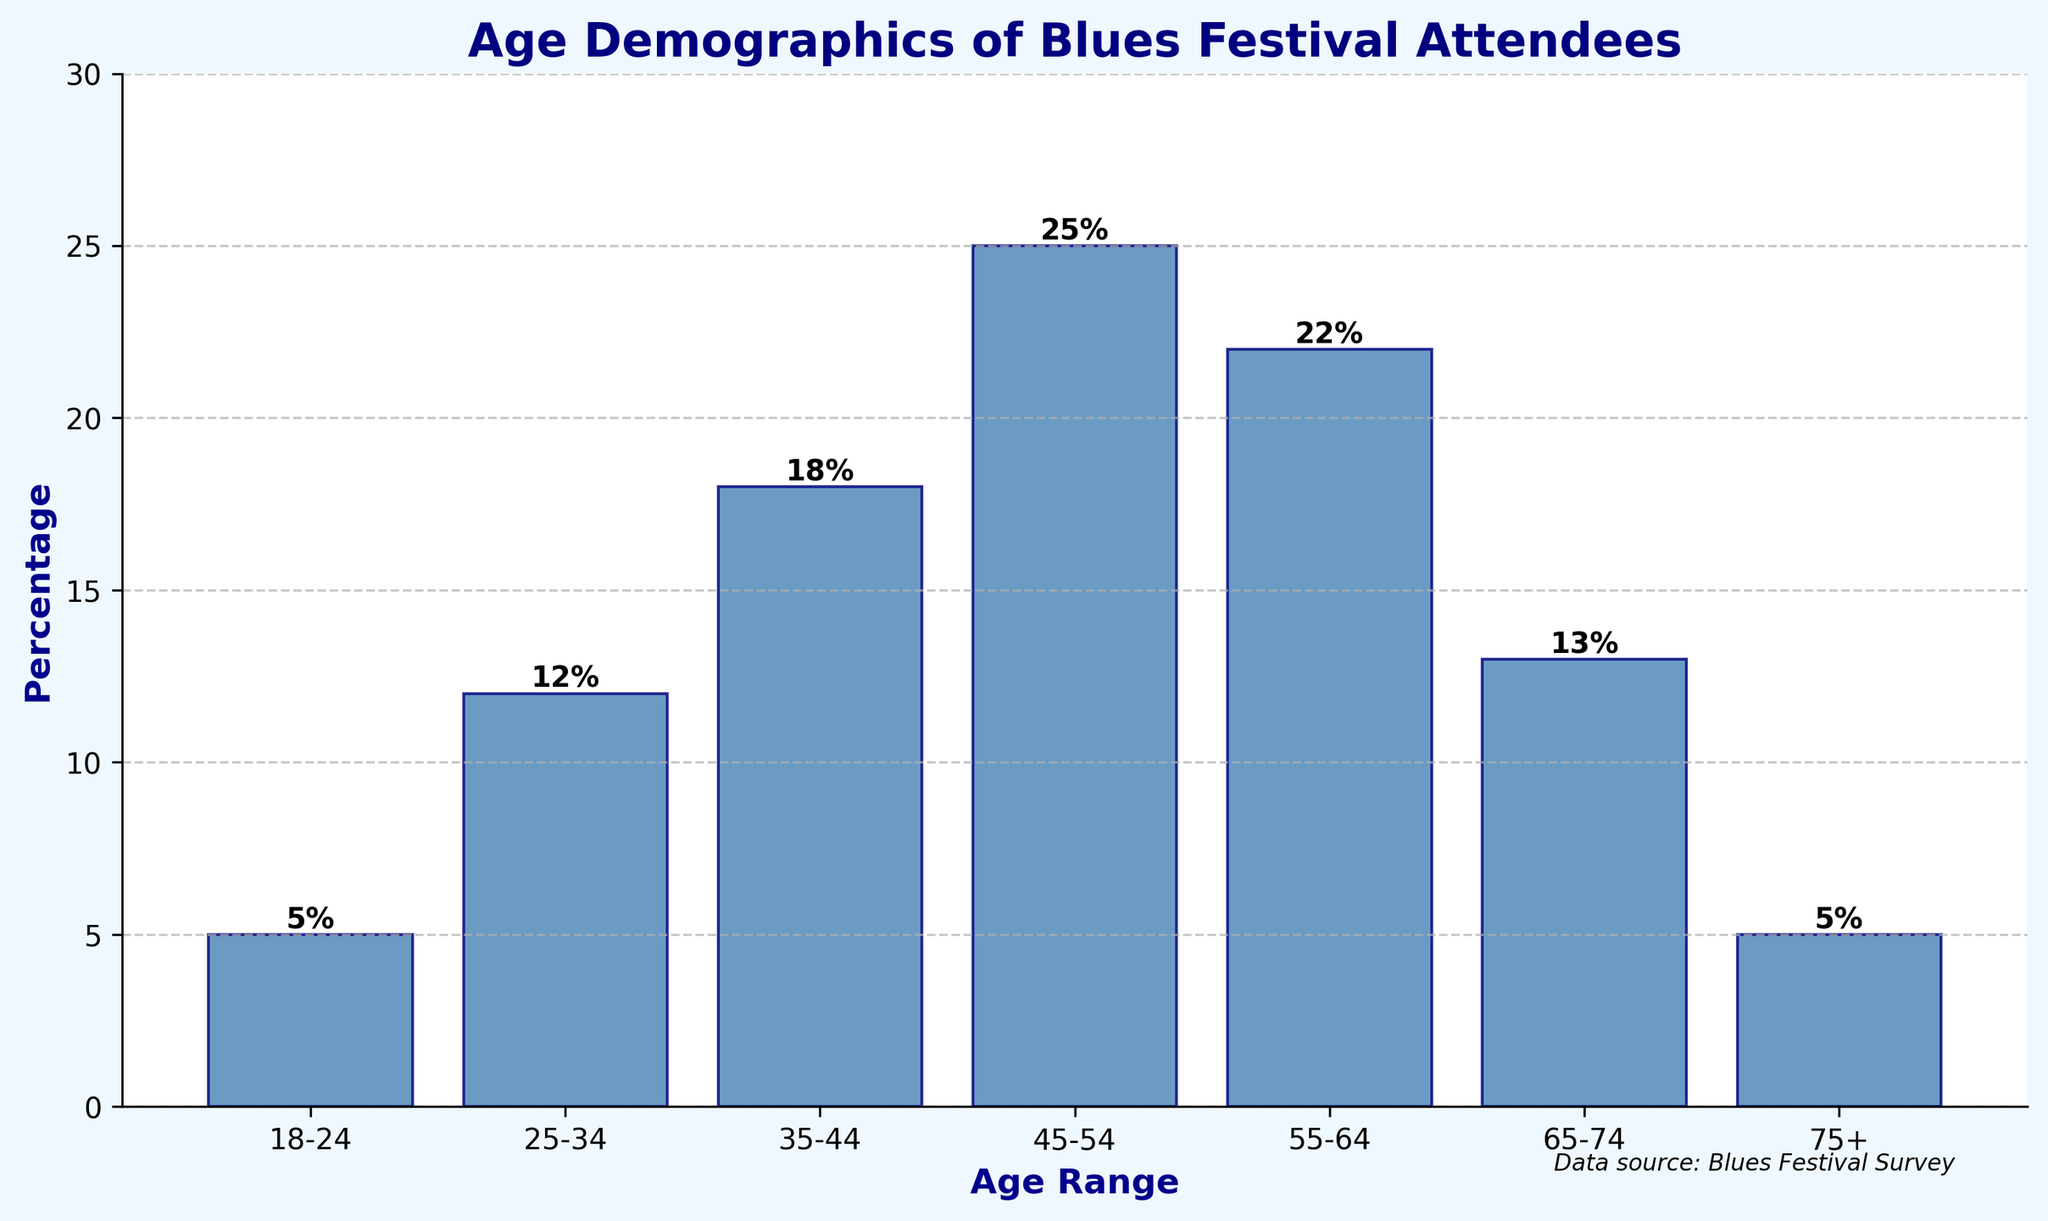Which age range has the highest percentage of attendees? By looking at the height of the bars, the age range with the highest attended percentage appears to be the tallest bar on the chart. The bar corresponding to the age range 45-54 is the tallest.
Answer: 45-54 What is the total percentage of attendees aged 35-44 and 55-64 combined? To find the total percentage, add the percentages for the age ranges 35-44 and 55-64. These are 18% and 22%, respectively. Therefore, the sum is 18% + 22%.
Answer: 40% Which two age ranges have equal percentages of attendees? By comparing the heights of the bars, we can see that the bars for age ranges 18-24 and 75+ have the same height, both representing 5%.
Answer: 18-24 and 75+ By how much does the percentage of attendees aged 45-54 exceed those aged 25-34? To find this, subtract the percentage for the 25-34 age range (12%) from the percentage of the 45-54 age range (25%). Therefore, 25% - 12% equals.
Answer: 13% What is the average percentage of attendees for the age ranges 18-24, 65-74, and 75+? Add the percentages for these age ranges together and then divide by the number of age ranges. So, (5% + 13% + 5%) / 3 = 23% / 3.
Answer: 7.67% Is the percentage of attendees in the age range 55-64 greater than the percentage of attendees in the age range 65-74? Compare the heights of the bars for the age ranges 55-64 (22%) and 65-74 (13%). Since 22% is greater than 13%, the percentage for 55-64 is indeed greater.
Answer: Yes What is the difference between the percentage of the youngest age range (18-24) and the oldest age range (75+)? The percentages for both age ranges are the same at 5%. Hence, their difference is 5% - 5%.
Answer: 0% Which age range has a percentage closest to 15%? The percentages are 5%, 12%, 18%, 25%, 22%, 13%, and 5%. Among these, the closest to 15% is 13%, which corresponds to the age range 65-74.
Answer: 65-74 